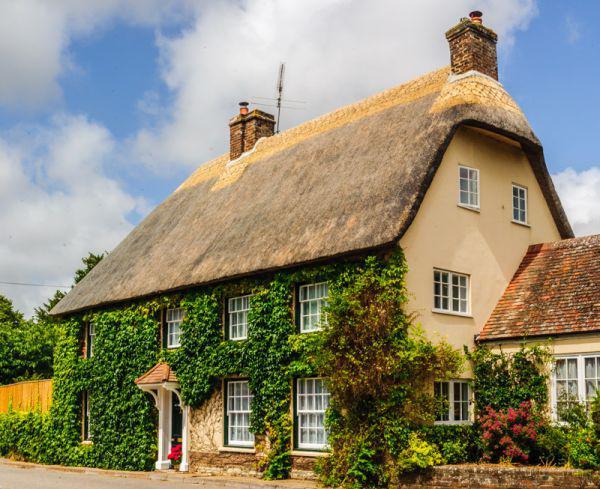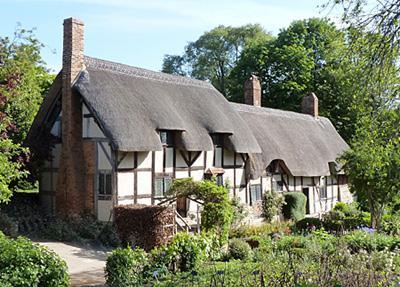The first image is the image on the left, the second image is the image on the right. Analyze the images presented: Is the assertion "There are three windows around the black door of the white house." valid? Answer yes or no. No. The first image is the image on the left, the second image is the image on the right. Examine the images to the left and right. Is the description "An image shows the front of a white house with bold dark lines on it forming geometric patterns, a chimney at at least one end, and a thick gray roof with at least one notched cut-out for windows." accurate? Answer yes or no. Yes. 